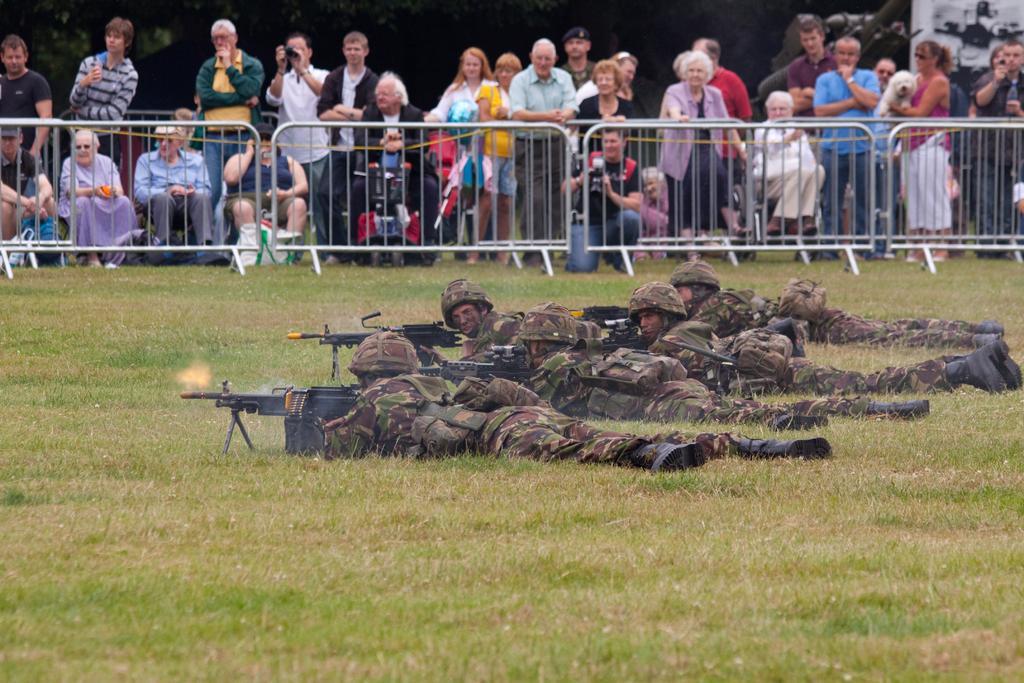In one or two sentences, can you explain what this image depicts? In this image I can see the group of people wearing the military uniforms and these people are holding the weapons. I can see these people are lying on the ground. In the background I can see the railing and many people with different color dresses. I can see there is a black background. 